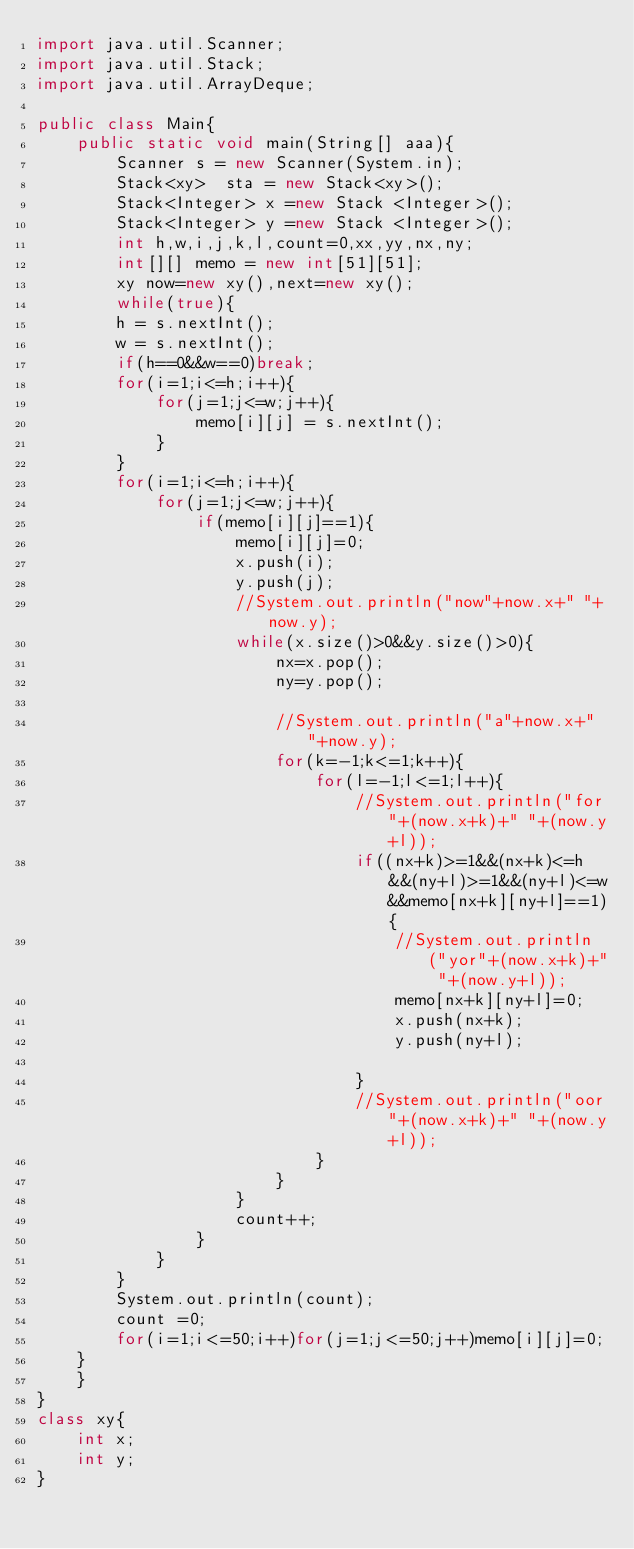Convert code to text. <code><loc_0><loc_0><loc_500><loc_500><_Java_>import java.util.Scanner;
import java.util.Stack;
import java.util.ArrayDeque;

public class Main{
    public static void main(String[] aaa){
        Scanner s = new Scanner(System.in);
        Stack<xy>  sta = new Stack<xy>();
        Stack<Integer> x =new Stack <Integer>();
        Stack<Integer> y =new Stack <Integer>();
        int h,w,i,j,k,l,count=0,xx,yy,nx,ny;
        int[][] memo = new int[51][51];
        xy now=new xy(),next=new xy();
        while(true){
        h = s.nextInt();
        w = s.nextInt();
        if(h==0&&w==0)break;
        for(i=1;i<=h;i++){
            for(j=1;j<=w;j++){
                memo[i][j] = s.nextInt();
            }
        }
        for(i=1;i<=h;i++){
            for(j=1;j<=w;j++){
                if(memo[i][j]==1){
                    memo[i][j]=0;
                    x.push(i);
                    y.push(j);
                    //System.out.println("now"+now.x+" "+now.y);
                    while(x.size()>0&&y.size()>0){
                        nx=x.pop();
                        ny=y.pop();
                        
                        //System.out.println("a"+now.x+" "+now.y);
                        for(k=-1;k<=1;k++){
                            for(l=-1;l<=1;l++){
                                //System.out.println("for"+(now.x+k)+" "+(now.y+l));
                                if((nx+k)>=1&&(nx+k)<=h&&(ny+l)>=1&&(ny+l)<=w&&memo[nx+k][ny+l]==1){
                                    //System.out.println("yor"+(now.x+k)+" "+(now.y+l));
                                    memo[nx+k][ny+l]=0;
                                    x.push(nx+k);
                                    y.push(ny+l);
                                
                                }
                                //System.out.println("oor"+(now.x+k)+" "+(now.y+l));
                            }
                        }
                    }
                    count++;
                }
            }
        }
        System.out.println(count);
        count =0;
        for(i=1;i<=50;i++)for(j=1;j<=50;j++)memo[i][j]=0;
    }
    }
}
class xy{
    int x;
    int y;
}
</code> 